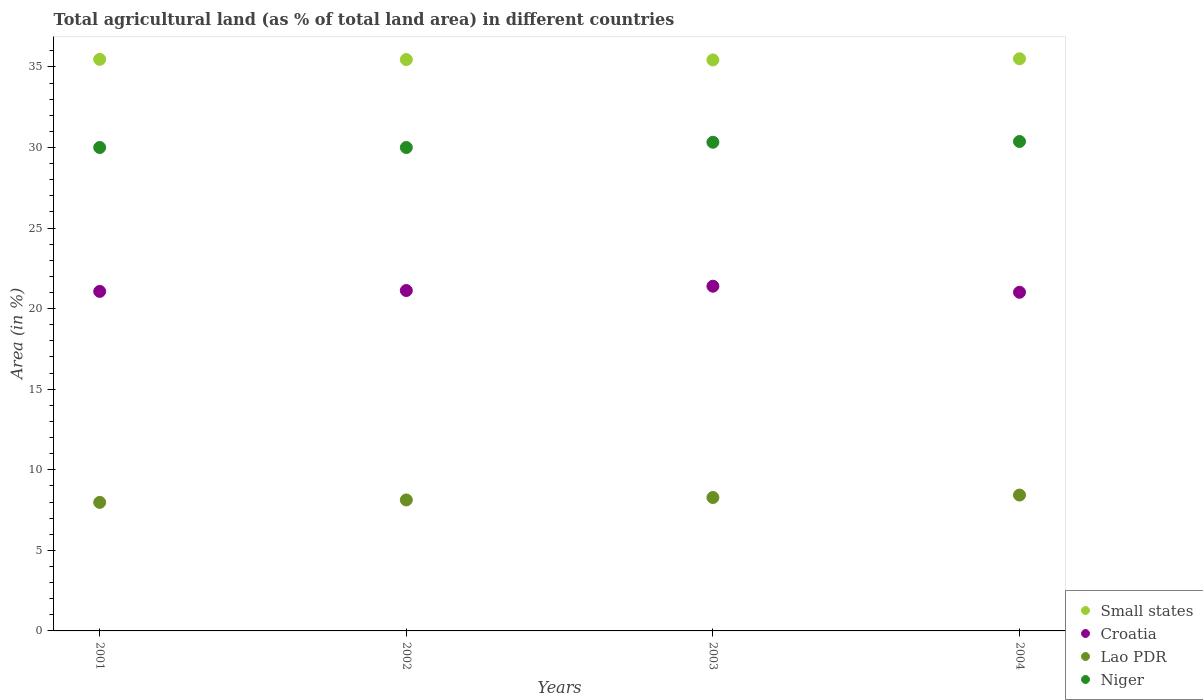What is the percentage of agricultural land in Niger in 2003?
Give a very brief answer. 30.32. Across all years, what is the maximum percentage of agricultural land in Croatia?
Your response must be concise. 21.39. Across all years, what is the minimum percentage of agricultural land in Lao PDR?
Your answer should be compact. 7.98. What is the total percentage of agricultural land in Croatia in the graph?
Provide a succinct answer. 84.6. What is the difference between the percentage of agricultural land in Croatia in 2001 and that in 2002?
Make the answer very short. -0.05. What is the difference between the percentage of agricultural land in Croatia in 2003 and the percentage of agricultural land in Small states in 2001?
Offer a terse response. -14.08. What is the average percentage of agricultural land in Lao PDR per year?
Ensure brevity in your answer.  8.2. In the year 2004, what is the difference between the percentage of agricultural land in Croatia and percentage of agricultural land in Lao PDR?
Your response must be concise. 12.58. What is the ratio of the percentage of agricultural land in Niger in 2002 to that in 2003?
Make the answer very short. 0.99. Is the percentage of agricultural land in Niger in 2003 less than that in 2004?
Offer a terse response. Yes. Is the difference between the percentage of agricultural land in Croatia in 2002 and 2004 greater than the difference between the percentage of agricultural land in Lao PDR in 2002 and 2004?
Make the answer very short. Yes. What is the difference between the highest and the second highest percentage of agricultural land in Croatia?
Your answer should be compact. 0.27. What is the difference between the highest and the lowest percentage of agricultural land in Niger?
Provide a short and direct response. 0.37. Is it the case that in every year, the sum of the percentage of agricultural land in Niger and percentage of agricultural land in Lao PDR  is greater than the percentage of agricultural land in Croatia?
Ensure brevity in your answer.  Yes. Does the percentage of agricultural land in Croatia monotonically increase over the years?
Ensure brevity in your answer.  No. Is the percentage of agricultural land in Niger strictly greater than the percentage of agricultural land in Lao PDR over the years?
Provide a succinct answer. Yes. Is the percentage of agricultural land in Small states strictly less than the percentage of agricultural land in Croatia over the years?
Ensure brevity in your answer.  No. How many dotlines are there?
Offer a terse response. 4. How many years are there in the graph?
Offer a very short reply. 4. Are the values on the major ticks of Y-axis written in scientific E-notation?
Keep it short and to the point. No. Does the graph contain any zero values?
Offer a terse response. No. Does the graph contain grids?
Provide a short and direct response. No. Where does the legend appear in the graph?
Ensure brevity in your answer.  Bottom right. How many legend labels are there?
Your answer should be compact. 4. How are the legend labels stacked?
Your response must be concise. Vertical. What is the title of the graph?
Provide a succinct answer. Total agricultural land (as % of total land area) in different countries. What is the label or title of the Y-axis?
Make the answer very short. Area (in %). What is the Area (in %) in Small states in 2001?
Your answer should be very brief. 35.47. What is the Area (in %) of Croatia in 2001?
Provide a succinct answer. 21.07. What is the Area (in %) of Lao PDR in 2001?
Offer a very short reply. 7.98. What is the Area (in %) in Niger in 2001?
Offer a terse response. 30. What is the Area (in %) of Small states in 2002?
Provide a short and direct response. 35.46. What is the Area (in %) in Croatia in 2002?
Offer a terse response. 21.12. What is the Area (in %) of Lao PDR in 2002?
Offer a terse response. 8.13. What is the Area (in %) in Niger in 2002?
Provide a short and direct response. 30. What is the Area (in %) in Small states in 2003?
Make the answer very short. 35.43. What is the Area (in %) of Croatia in 2003?
Offer a terse response. 21.39. What is the Area (in %) of Lao PDR in 2003?
Ensure brevity in your answer.  8.28. What is the Area (in %) of Niger in 2003?
Make the answer very short. 30.32. What is the Area (in %) in Small states in 2004?
Provide a short and direct response. 35.51. What is the Area (in %) in Croatia in 2004?
Keep it short and to the point. 21.02. What is the Area (in %) in Lao PDR in 2004?
Provide a succinct answer. 8.43. What is the Area (in %) of Niger in 2004?
Give a very brief answer. 30.37. Across all years, what is the maximum Area (in %) of Small states?
Ensure brevity in your answer.  35.51. Across all years, what is the maximum Area (in %) in Croatia?
Offer a terse response. 21.39. Across all years, what is the maximum Area (in %) of Lao PDR?
Ensure brevity in your answer.  8.43. Across all years, what is the maximum Area (in %) of Niger?
Provide a short and direct response. 30.37. Across all years, what is the minimum Area (in %) of Small states?
Provide a succinct answer. 35.43. Across all years, what is the minimum Area (in %) of Croatia?
Provide a short and direct response. 21.02. Across all years, what is the minimum Area (in %) of Lao PDR?
Your response must be concise. 7.98. Across all years, what is the minimum Area (in %) in Niger?
Your response must be concise. 30. What is the total Area (in %) of Small states in the graph?
Your response must be concise. 141.86. What is the total Area (in %) of Croatia in the graph?
Your answer should be very brief. 84.6. What is the total Area (in %) in Lao PDR in the graph?
Your answer should be very brief. 32.82. What is the total Area (in %) of Niger in the graph?
Ensure brevity in your answer.  120.69. What is the difference between the Area (in %) of Small states in 2001 and that in 2002?
Make the answer very short. 0.01. What is the difference between the Area (in %) in Croatia in 2001 and that in 2002?
Offer a terse response. -0.05. What is the difference between the Area (in %) of Lao PDR in 2001 and that in 2002?
Your answer should be very brief. -0.15. What is the difference between the Area (in %) of Small states in 2001 and that in 2003?
Provide a short and direct response. 0.04. What is the difference between the Area (in %) in Croatia in 2001 and that in 2003?
Keep it short and to the point. -0.32. What is the difference between the Area (in %) of Lao PDR in 2001 and that in 2003?
Make the answer very short. -0.3. What is the difference between the Area (in %) of Niger in 2001 and that in 2003?
Provide a short and direct response. -0.33. What is the difference between the Area (in %) of Small states in 2001 and that in 2004?
Your response must be concise. -0.04. What is the difference between the Area (in %) in Croatia in 2001 and that in 2004?
Ensure brevity in your answer.  0.05. What is the difference between the Area (in %) of Lao PDR in 2001 and that in 2004?
Offer a very short reply. -0.45. What is the difference between the Area (in %) of Niger in 2001 and that in 2004?
Provide a short and direct response. -0.37. What is the difference between the Area (in %) of Small states in 2002 and that in 2003?
Your answer should be compact. 0.02. What is the difference between the Area (in %) of Croatia in 2002 and that in 2003?
Offer a very short reply. -0.27. What is the difference between the Area (in %) of Lao PDR in 2002 and that in 2003?
Your answer should be compact. -0.15. What is the difference between the Area (in %) in Niger in 2002 and that in 2003?
Your answer should be compact. -0.33. What is the difference between the Area (in %) in Small states in 2002 and that in 2004?
Make the answer very short. -0.05. What is the difference between the Area (in %) in Croatia in 2002 and that in 2004?
Ensure brevity in your answer.  0.11. What is the difference between the Area (in %) in Lao PDR in 2002 and that in 2004?
Offer a very short reply. -0.3. What is the difference between the Area (in %) of Niger in 2002 and that in 2004?
Provide a short and direct response. -0.37. What is the difference between the Area (in %) of Small states in 2003 and that in 2004?
Keep it short and to the point. -0.07. What is the difference between the Area (in %) of Croatia in 2003 and that in 2004?
Offer a terse response. 0.38. What is the difference between the Area (in %) of Lao PDR in 2003 and that in 2004?
Your answer should be very brief. -0.15. What is the difference between the Area (in %) of Niger in 2003 and that in 2004?
Make the answer very short. -0.05. What is the difference between the Area (in %) in Small states in 2001 and the Area (in %) in Croatia in 2002?
Your answer should be very brief. 14.35. What is the difference between the Area (in %) of Small states in 2001 and the Area (in %) of Lao PDR in 2002?
Your response must be concise. 27.34. What is the difference between the Area (in %) in Small states in 2001 and the Area (in %) in Niger in 2002?
Your response must be concise. 5.47. What is the difference between the Area (in %) in Croatia in 2001 and the Area (in %) in Lao PDR in 2002?
Provide a succinct answer. 12.94. What is the difference between the Area (in %) of Croatia in 2001 and the Area (in %) of Niger in 2002?
Keep it short and to the point. -8.93. What is the difference between the Area (in %) of Lao PDR in 2001 and the Area (in %) of Niger in 2002?
Provide a short and direct response. -22.02. What is the difference between the Area (in %) of Small states in 2001 and the Area (in %) of Croatia in 2003?
Offer a terse response. 14.08. What is the difference between the Area (in %) of Small states in 2001 and the Area (in %) of Lao PDR in 2003?
Provide a short and direct response. 27.19. What is the difference between the Area (in %) of Small states in 2001 and the Area (in %) of Niger in 2003?
Your answer should be very brief. 5.14. What is the difference between the Area (in %) in Croatia in 2001 and the Area (in %) in Lao PDR in 2003?
Provide a succinct answer. 12.79. What is the difference between the Area (in %) of Croatia in 2001 and the Area (in %) of Niger in 2003?
Provide a succinct answer. -9.25. What is the difference between the Area (in %) of Lao PDR in 2001 and the Area (in %) of Niger in 2003?
Keep it short and to the point. -22.35. What is the difference between the Area (in %) in Small states in 2001 and the Area (in %) in Croatia in 2004?
Provide a succinct answer. 14.45. What is the difference between the Area (in %) in Small states in 2001 and the Area (in %) in Lao PDR in 2004?
Offer a very short reply. 27.04. What is the difference between the Area (in %) of Small states in 2001 and the Area (in %) of Niger in 2004?
Provide a succinct answer. 5.1. What is the difference between the Area (in %) in Croatia in 2001 and the Area (in %) in Lao PDR in 2004?
Your answer should be very brief. 12.64. What is the difference between the Area (in %) in Croatia in 2001 and the Area (in %) in Niger in 2004?
Provide a succinct answer. -9.3. What is the difference between the Area (in %) in Lao PDR in 2001 and the Area (in %) in Niger in 2004?
Your response must be concise. -22.4. What is the difference between the Area (in %) in Small states in 2002 and the Area (in %) in Croatia in 2003?
Make the answer very short. 14.06. What is the difference between the Area (in %) of Small states in 2002 and the Area (in %) of Lao PDR in 2003?
Make the answer very short. 27.18. What is the difference between the Area (in %) in Small states in 2002 and the Area (in %) in Niger in 2003?
Provide a short and direct response. 5.13. What is the difference between the Area (in %) in Croatia in 2002 and the Area (in %) in Lao PDR in 2003?
Offer a terse response. 12.84. What is the difference between the Area (in %) of Croatia in 2002 and the Area (in %) of Niger in 2003?
Make the answer very short. -9.2. What is the difference between the Area (in %) of Lao PDR in 2002 and the Area (in %) of Niger in 2003?
Make the answer very short. -22.2. What is the difference between the Area (in %) in Small states in 2002 and the Area (in %) in Croatia in 2004?
Provide a short and direct response. 14.44. What is the difference between the Area (in %) in Small states in 2002 and the Area (in %) in Lao PDR in 2004?
Your response must be concise. 27.02. What is the difference between the Area (in %) in Small states in 2002 and the Area (in %) in Niger in 2004?
Keep it short and to the point. 5.08. What is the difference between the Area (in %) in Croatia in 2002 and the Area (in %) in Lao PDR in 2004?
Ensure brevity in your answer.  12.69. What is the difference between the Area (in %) in Croatia in 2002 and the Area (in %) in Niger in 2004?
Make the answer very short. -9.25. What is the difference between the Area (in %) in Lao PDR in 2002 and the Area (in %) in Niger in 2004?
Make the answer very short. -22.24. What is the difference between the Area (in %) in Small states in 2003 and the Area (in %) in Croatia in 2004?
Offer a very short reply. 14.42. What is the difference between the Area (in %) in Small states in 2003 and the Area (in %) in Lao PDR in 2004?
Your answer should be compact. 27. What is the difference between the Area (in %) of Small states in 2003 and the Area (in %) of Niger in 2004?
Your answer should be very brief. 5.06. What is the difference between the Area (in %) of Croatia in 2003 and the Area (in %) of Lao PDR in 2004?
Your answer should be compact. 12.96. What is the difference between the Area (in %) in Croatia in 2003 and the Area (in %) in Niger in 2004?
Give a very brief answer. -8.98. What is the difference between the Area (in %) of Lao PDR in 2003 and the Area (in %) of Niger in 2004?
Keep it short and to the point. -22.09. What is the average Area (in %) in Small states per year?
Your response must be concise. 35.47. What is the average Area (in %) in Croatia per year?
Give a very brief answer. 21.15. What is the average Area (in %) of Lao PDR per year?
Give a very brief answer. 8.2. What is the average Area (in %) in Niger per year?
Provide a short and direct response. 30.17. In the year 2001, what is the difference between the Area (in %) of Small states and Area (in %) of Croatia?
Your response must be concise. 14.4. In the year 2001, what is the difference between the Area (in %) of Small states and Area (in %) of Lao PDR?
Keep it short and to the point. 27.49. In the year 2001, what is the difference between the Area (in %) in Small states and Area (in %) in Niger?
Provide a short and direct response. 5.47. In the year 2001, what is the difference between the Area (in %) of Croatia and Area (in %) of Lao PDR?
Make the answer very short. 13.09. In the year 2001, what is the difference between the Area (in %) in Croatia and Area (in %) in Niger?
Provide a short and direct response. -8.93. In the year 2001, what is the difference between the Area (in %) in Lao PDR and Area (in %) in Niger?
Keep it short and to the point. -22.02. In the year 2002, what is the difference between the Area (in %) in Small states and Area (in %) in Croatia?
Your answer should be very brief. 14.33. In the year 2002, what is the difference between the Area (in %) of Small states and Area (in %) of Lao PDR?
Your response must be concise. 27.33. In the year 2002, what is the difference between the Area (in %) in Small states and Area (in %) in Niger?
Provide a short and direct response. 5.46. In the year 2002, what is the difference between the Area (in %) in Croatia and Area (in %) in Lao PDR?
Your answer should be very brief. 12.99. In the year 2002, what is the difference between the Area (in %) of Croatia and Area (in %) of Niger?
Offer a very short reply. -8.88. In the year 2002, what is the difference between the Area (in %) of Lao PDR and Area (in %) of Niger?
Your answer should be very brief. -21.87. In the year 2003, what is the difference between the Area (in %) in Small states and Area (in %) in Croatia?
Provide a succinct answer. 14.04. In the year 2003, what is the difference between the Area (in %) in Small states and Area (in %) in Lao PDR?
Your response must be concise. 27.15. In the year 2003, what is the difference between the Area (in %) of Small states and Area (in %) of Niger?
Provide a short and direct response. 5.11. In the year 2003, what is the difference between the Area (in %) in Croatia and Area (in %) in Lao PDR?
Provide a succinct answer. 13.11. In the year 2003, what is the difference between the Area (in %) in Croatia and Area (in %) in Niger?
Your response must be concise. -8.93. In the year 2003, what is the difference between the Area (in %) in Lao PDR and Area (in %) in Niger?
Keep it short and to the point. -22.04. In the year 2004, what is the difference between the Area (in %) in Small states and Area (in %) in Croatia?
Your answer should be very brief. 14.49. In the year 2004, what is the difference between the Area (in %) of Small states and Area (in %) of Lao PDR?
Provide a succinct answer. 27.07. In the year 2004, what is the difference between the Area (in %) of Small states and Area (in %) of Niger?
Ensure brevity in your answer.  5.13. In the year 2004, what is the difference between the Area (in %) in Croatia and Area (in %) in Lao PDR?
Offer a terse response. 12.58. In the year 2004, what is the difference between the Area (in %) in Croatia and Area (in %) in Niger?
Provide a succinct answer. -9.36. In the year 2004, what is the difference between the Area (in %) of Lao PDR and Area (in %) of Niger?
Your answer should be very brief. -21.94. What is the ratio of the Area (in %) in Small states in 2001 to that in 2002?
Ensure brevity in your answer.  1. What is the ratio of the Area (in %) in Croatia in 2001 to that in 2002?
Your answer should be very brief. 1. What is the ratio of the Area (in %) of Lao PDR in 2001 to that in 2002?
Your answer should be compact. 0.98. What is the ratio of the Area (in %) in Small states in 2001 to that in 2003?
Your answer should be compact. 1. What is the ratio of the Area (in %) in Croatia in 2001 to that in 2003?
Keep it short and to the point. 0.98. What is the ratio of the Area (in %) in Lao PDR in 2001 to that in 2003?
Keep it short and to the point. 0.96. What is the ratio of the Area (in %) in Niger in 2001 to that in 2003?
Offer a very short reply. 0.99. What is the ratio of the Area (in %) of Small states in 2001 to that in 2004?
Provide a succinct answer. 1. What is the ratio of the Area (in %) in Lao PDR in 2001 to that in 2004?
Make the answer very short. 0.95. What is the ratio of the Area (in %) in Niger in 2001 to that in 2004?
Your answer should be compact. 0.99. What is the ratio of the Area (in %) of Croatia in 2002 to that in 2003?
Offer a very short reply. 0.99. What is the ratio of the Area (in %) in Lao PDR in 2002 to that in 2003?
Provide a short and direct response. 0.98. What is the ratio of the Area (in %) of Niger in 2002 to that in 2003?
Provide a succinct answer. 0.99. What is the ratio of the Area (in %) of Small states in 2003 to that in 2004?
Give a very brief answer. 1. What is the ratio of the Area (in %) in Croatia in 2003 to that in 2004?
Keep it short and to the point. 1.02. What is the ratio of the Area (in %) of Lao PDR in 2003 to that in 2004?
Make the answer very short. 0.98. What is the difference between the highest and the second highest Area (in %) of Small states?
Your answer should be compact. 0.04. What is the difference between the highest and the second highest Area (in %) in Croatia?
Provide a succinct answer. 0.27. What is the difference between the highest and the second highest Area (in %) of Lao PDR?
Give a very brief answer. 0.15. What is the difference between the highest and the second highest Area (in %) of Niger?
Your answer should be very brief. 0.05. What is the difference between the highest and the lowest Area (in %) in Small states?
Provide a short and direct response. 0.07. What is the difference between the highest and the lowest Area (in %) of Croatia?
Your answer should be compact. 0.38. What is the difference between the highest and the lowest Area (in %) in Lao PDR?
Provide a short and direct response. 0.45. What is the difference between the highest and the lowest Area (in %) in Niger?
Provide a short and direct response. 0.37. 